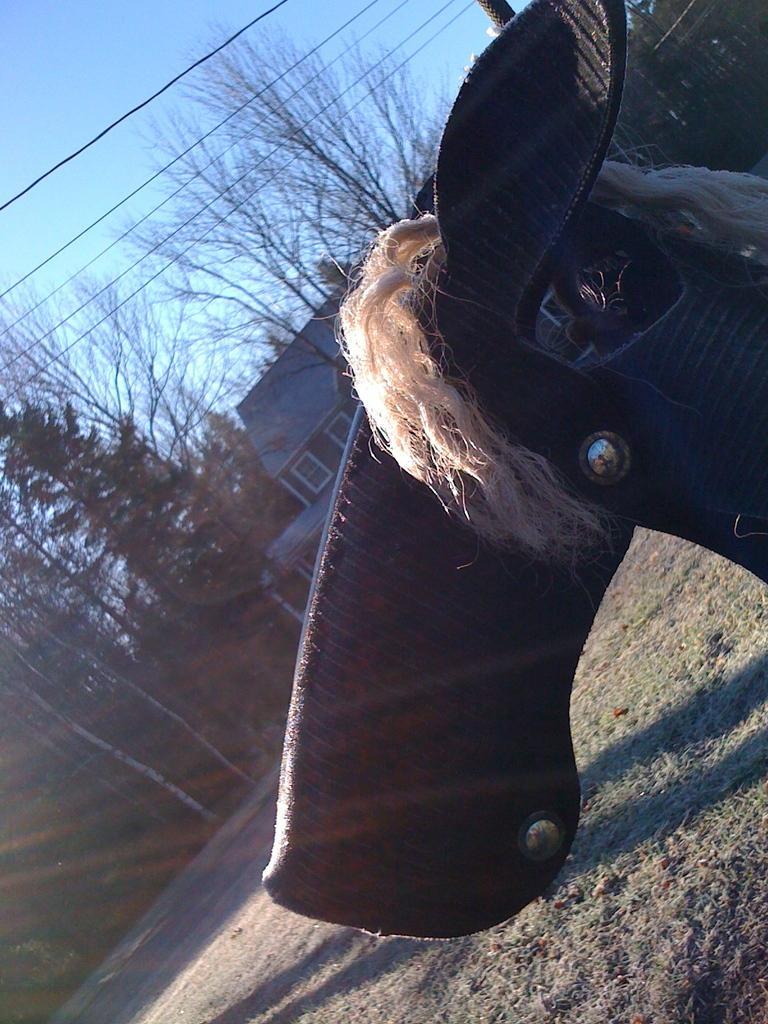Can you describe this image briefly? In this picture there is a leather object towards the right. On the object there are nuts and thread like structures. In the background there is a building, trees, wires and sky. 